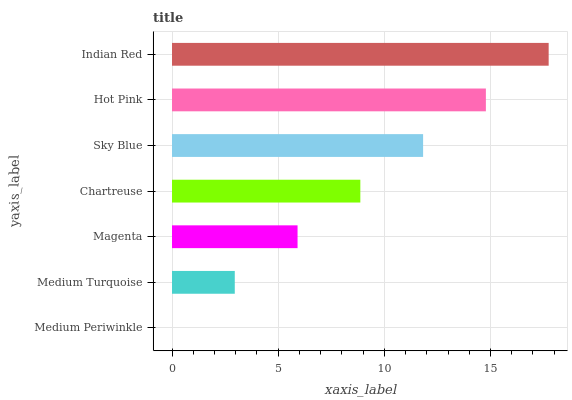Is Medium Periwinkle the minimum?
Answer yes or no. Yes. Is Indian Red the maximum?
Answer yes or no. Yes. Is Medium Turquoise the minimum?
Answer yes or no. No. Is Medium Turquoise the maximum?
Answer yes or no. No. Is Medium Turquoise greater than Medium Periwinkle?
Answer yes or no. Yes. Is Medium Periwinkle less than Medium Turquoise?
Answer yes or no. Yes. Is Medium Periwinkle greater than Medium Turquoise?
Answer yes or no. No. Is Medium Turquoise less than Medium Periwinkle?
Answer yes or no. No. Is Chartreuse the high median?
Answer yes or no. Yes. Is Chartreuse the low median?
Answer yes or no. Yes. Is Medium Turquoise the high median?
Answer yes or no. No. Is Hot Pink the low median?
Answer yes or no. No. 